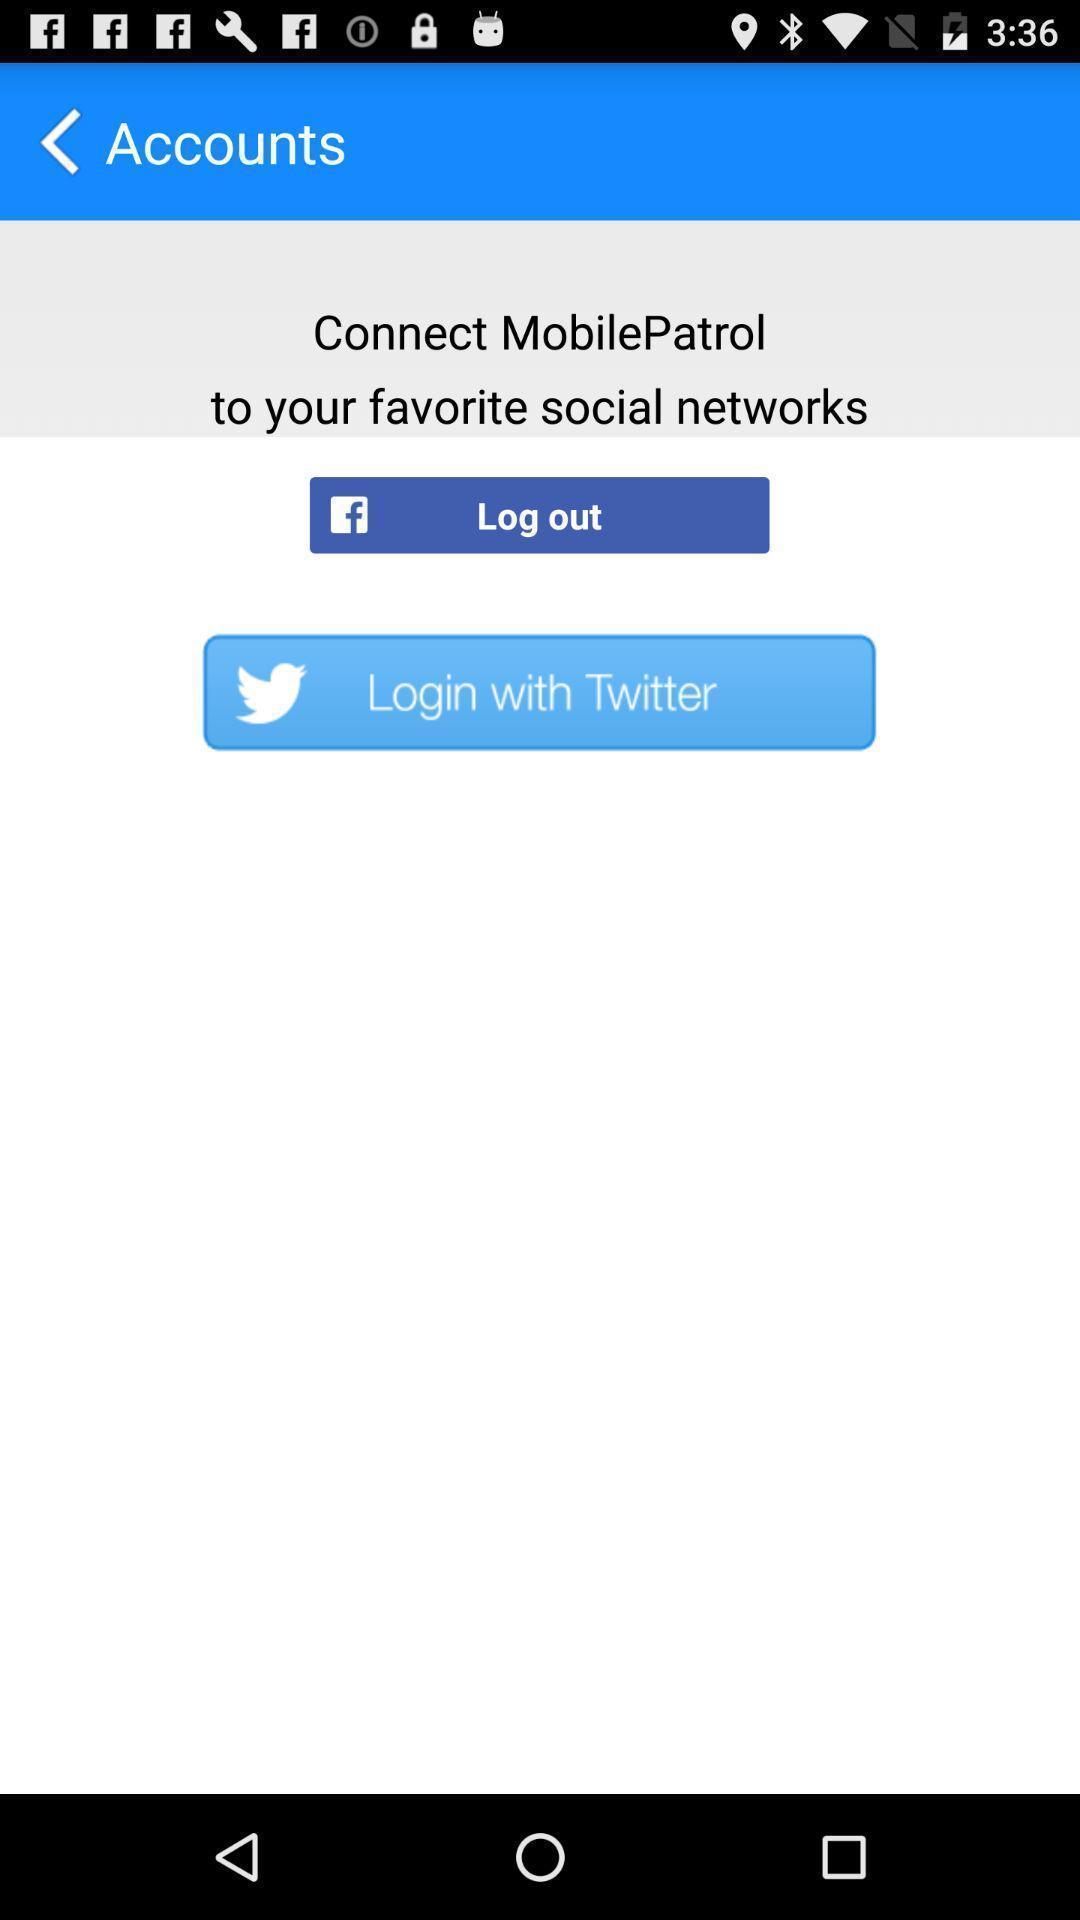What details can you identify in this image? Page displaying to connect an application through social apps. 